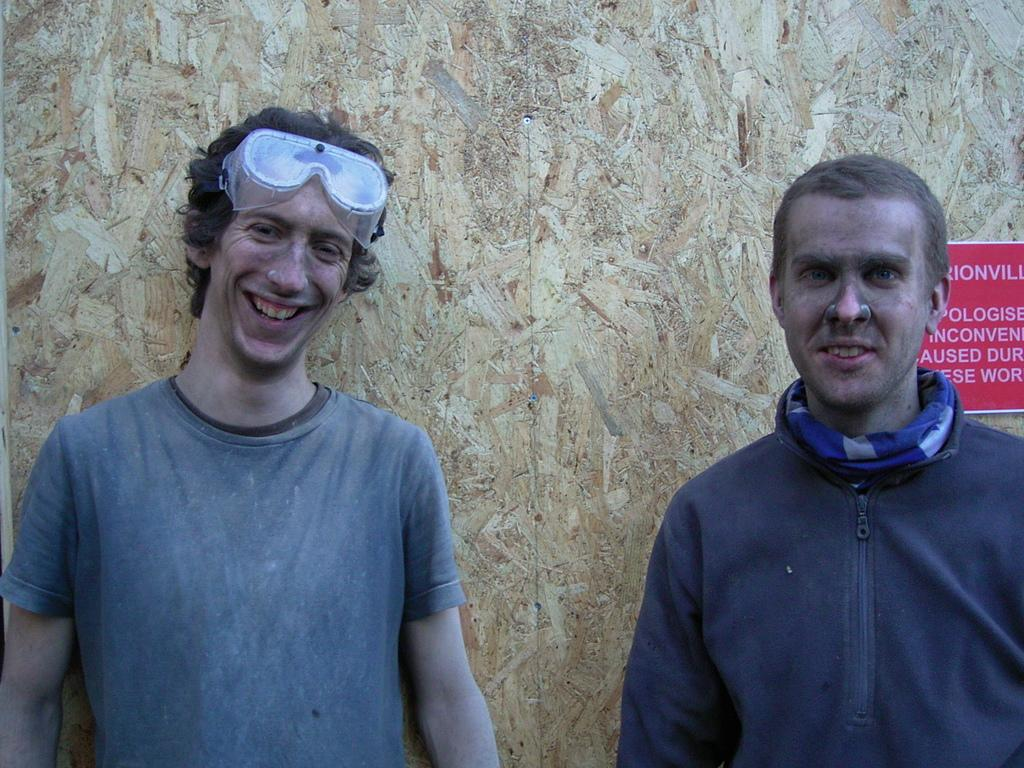How many people are present in the image? There are two people in the image. What can be observed about the clothing of the people in the image? The people are wearing different color dresses. What is visible on the wall in the background of the image? There is a red color board on the wall in the background of the image. What type of cannon is present in the image? There is no cannon present in the image. How does the design of the dresses contribute to the overall aesthetic of the image? The provided facts do not mention the design of the dresses, so we cannot comment on how it contributes to the overall aesthetic of the image. 